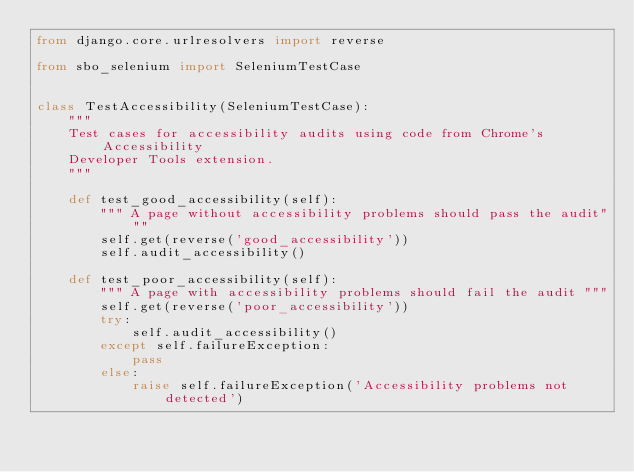Convert code to text. <code><loc_0><loc_0><loc_500><loc_500><_Python_>from django.core.urlresolvers import reverse

from sbo_selenium import SeleniumTestCase


class TestAccessibility(SeleniumTestCase):
    """
    Test cases for accessibility audits using code from Chrome's Accessibility
    Developer Tools extension.
    """

    def test_good_accessibility(self):
        """ A page without accessibility problems should pass the audit"""
        self.get(reverse('good_accessibility'))
        self.audit_accessibility()

    def test_poor_accessibility(self):
        """ A page with accessibility problems should fail the audit """
        self.get(reverse('poor_accessibility'))
        try:
            self.audit_accessibility()
        except self.failureException:
            pass
        else:
            raise self.failureException('Accessibility problems not detected')
</code> 